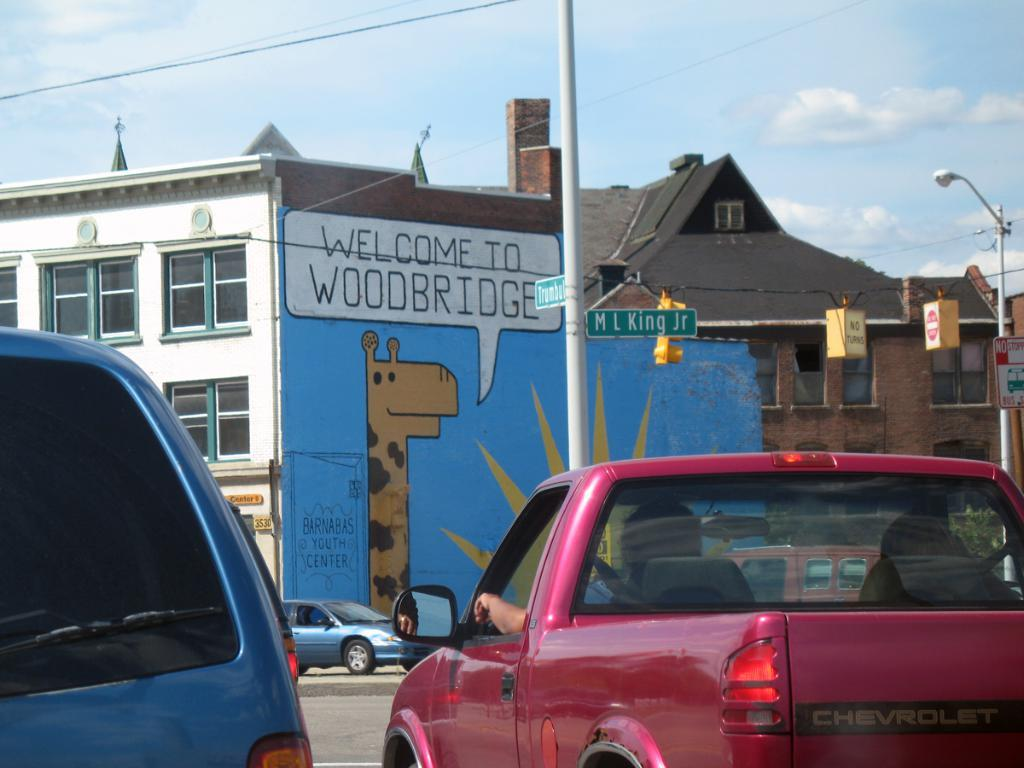What is happening on the road in the image? There are two vehicles moving on the road in the image. What structure can be seen in the image? There is a building in the image. What is depicted on the building? The building has a painting of a giraffe. What is visible at the top of the image? The sky is visible at the top of the image. How does the glove provide comfort to the giraffe in the image? There is no glove present in the image, and the giraffe is a painting on the building. What type of shock can be seen in the image? There is no shock present in the image; it features two vehicles moving on the road, a building with a giraffe painting, and the sky. 